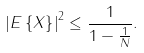Convert formula to latex. <formula><loc_0><loc_0><loc_500><loc_500>& \left | E \left \{ X \right \} \right | ^ { 2 } \leq \frac { 1 } { 1 - \frac { 1 } { N } } .</formula> 